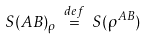Convert formula to latex. <formula><loc_0><loc_0><loc_500><loc_500>S ( A B ) _ { \rho } \ { \stackrel { d e f } { = } } \ S ( \rho ^ { A B } )</formula> 